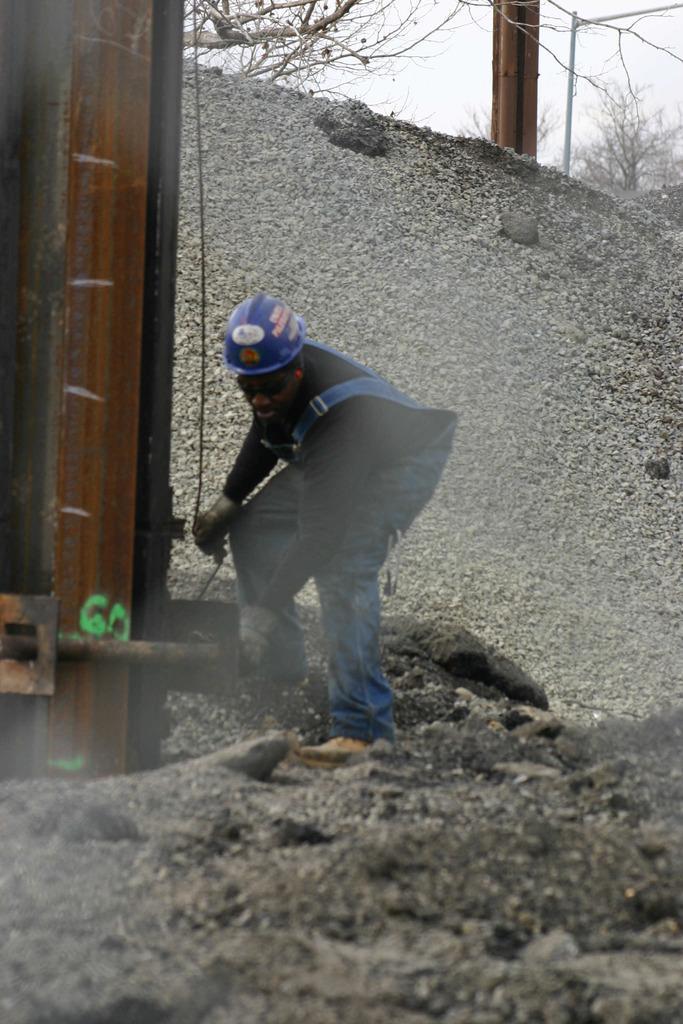Please provide a concise description of this image. In this image I can see a person holding a wire. In the background, I can see the trees. 